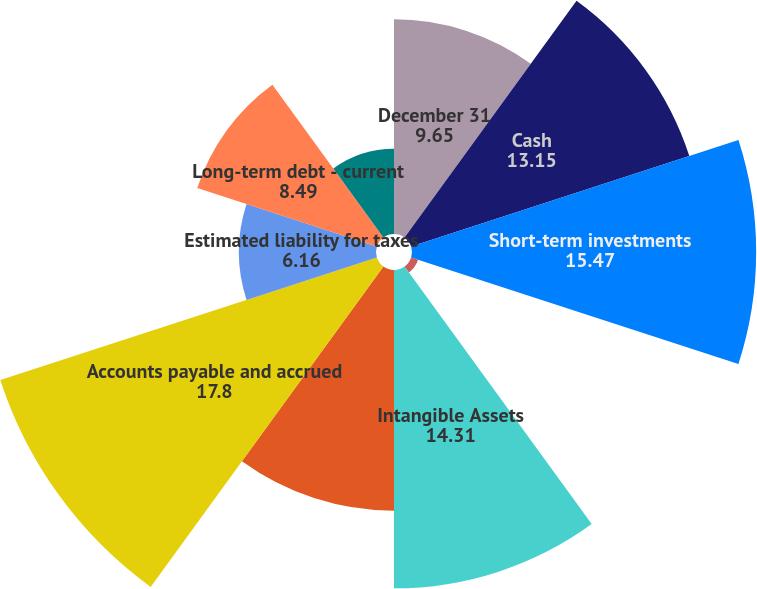Convert chart to OTSL. <chart><loc_0><loc_0><loc_500><loc_500><pie_chart><fcel>December 31<fcel>Cash<fcel>Short-term investments<fcel>Deferred taxes<fcel>Intangible Assets<fcel>Other Assets<fcel>Accounts payable and accrued<fcel>Estimated liability for taxes<fcel>Long-term debt - current<fcel>Short-term borrowings<nl><fcel>9.65%<fcel>13.15%<fcel>15.47%<fcel>0.33%<fcel>14.31%<fcel>10.82%<fcel>17.8%<fcel>6.16%<fcel>8.49%<fcel>3.83%<nl></chart> 